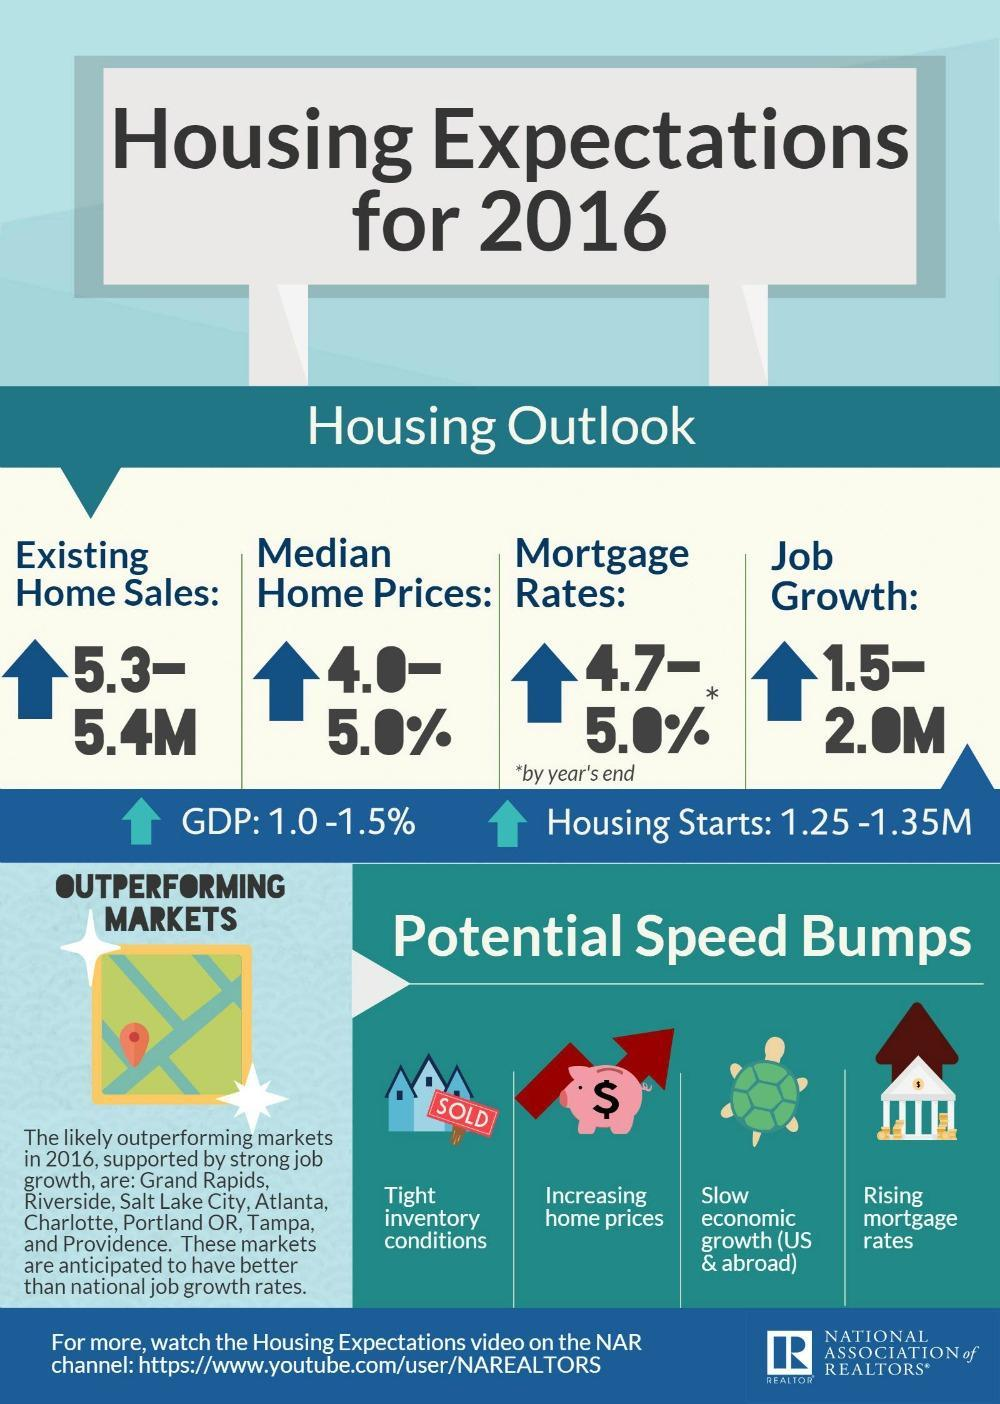What is the existing home sale in 2016, 5.3-5.4M, 1.5-2.0M, or 1.25-1.35M?
Answer the question with a short phrase. 5.3-5.4M 